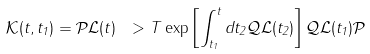Convert formula to latex. <formula><loc_0><loc_0><loc_500><loc_500>\mathcal { K } ( t , t _ { 1 } ) = \mathcal { P } \mathcal { L } ( t ) \ > T \exp \left [ \int _ { t _ { 1 } } ^ { t } d t _ { 2 } \mathcal { Q } \mathcal { L } ( t _ { 2 } ) \right ] \mathcal { Q } \mathcal { L } ( t _ { 1 } ) \mathcal { P }</formula> 